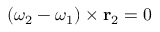Convert formula to latex. <formula><loc_0><loc_0><loc_500><loc_500>( { \omega } _ { 2 } - { \omega } _ { 1 } ) \times r _ { 2 } = 0</formula> 